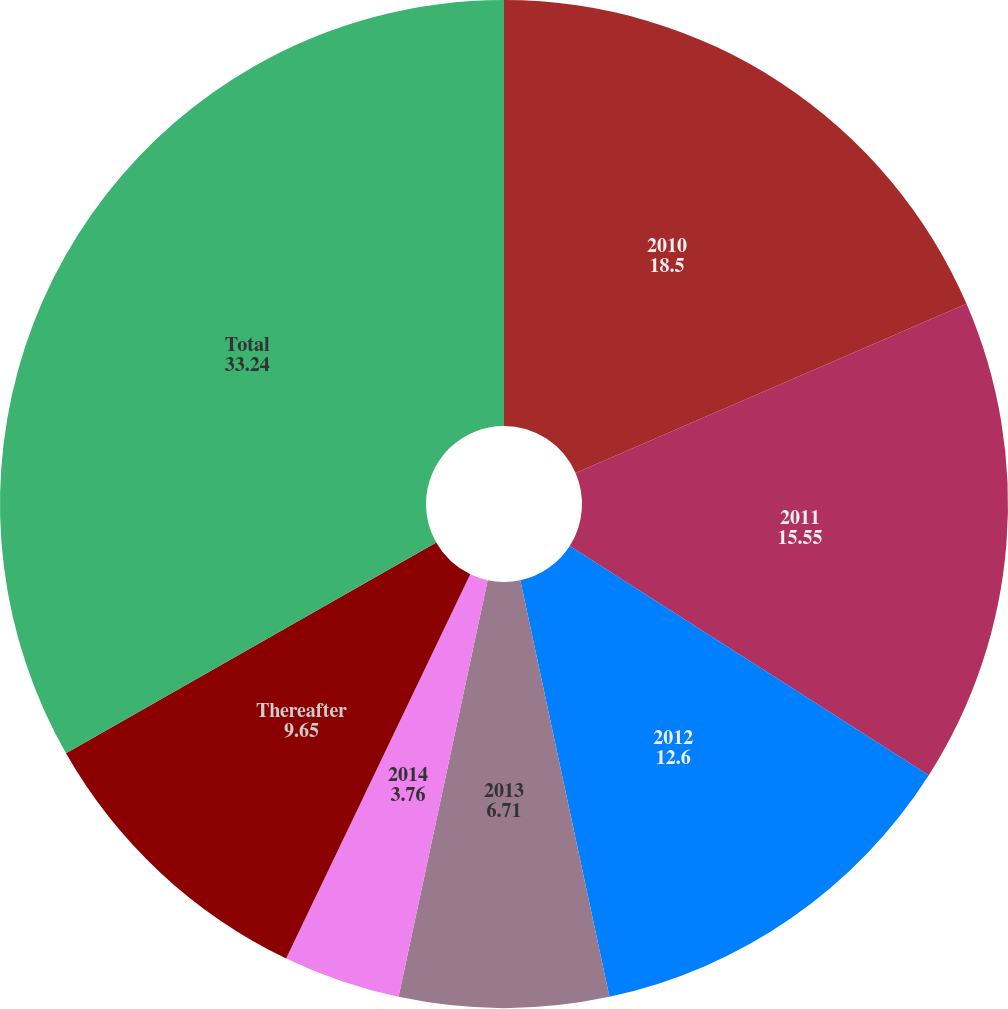<chart> <loc_0><loc_0><loc_500><loc_500><pie_chart><fcel>2010<fcel>2011<fcel>2012<fcel>2013<fcel>2014<fcel>Thereafter<fcel>Total<nl><fcel>18.5%<fcel>15.55%<fcel>12.6%<fcel>6.71%<fcel>3.76%<fcel>9.65%<fcel>33.24%<nl></chart> 